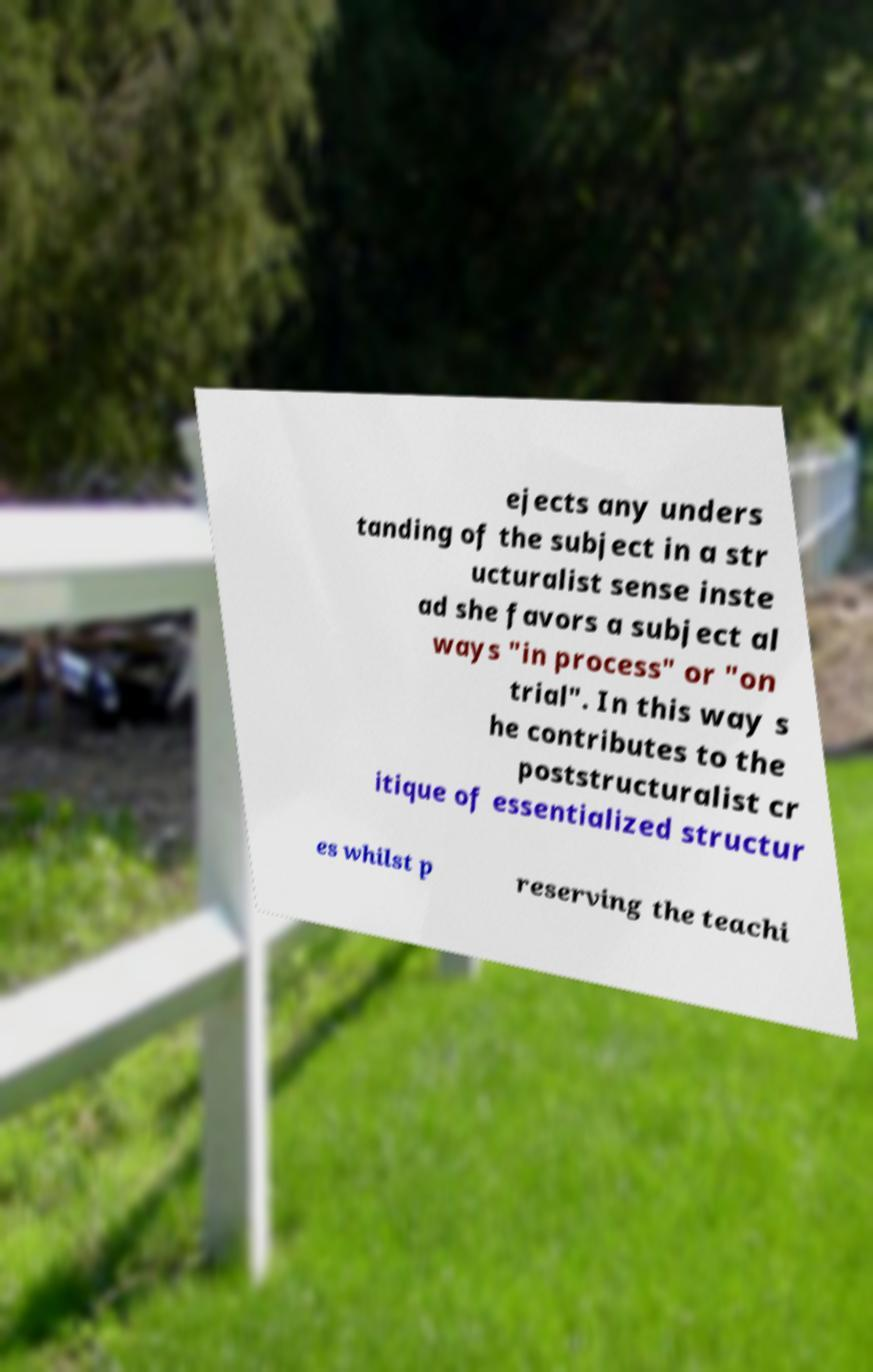For documentation purposes, I need the text within this image transcribed. Could you provide that? ejects any unders tanding of the subject in a str ucturalist sense inste ad she favors a subject al ways "in process" or "on trial". In this way s he contributes to the poststructuralist cr itique of essentialized structur es whilst p reserving the teachi 